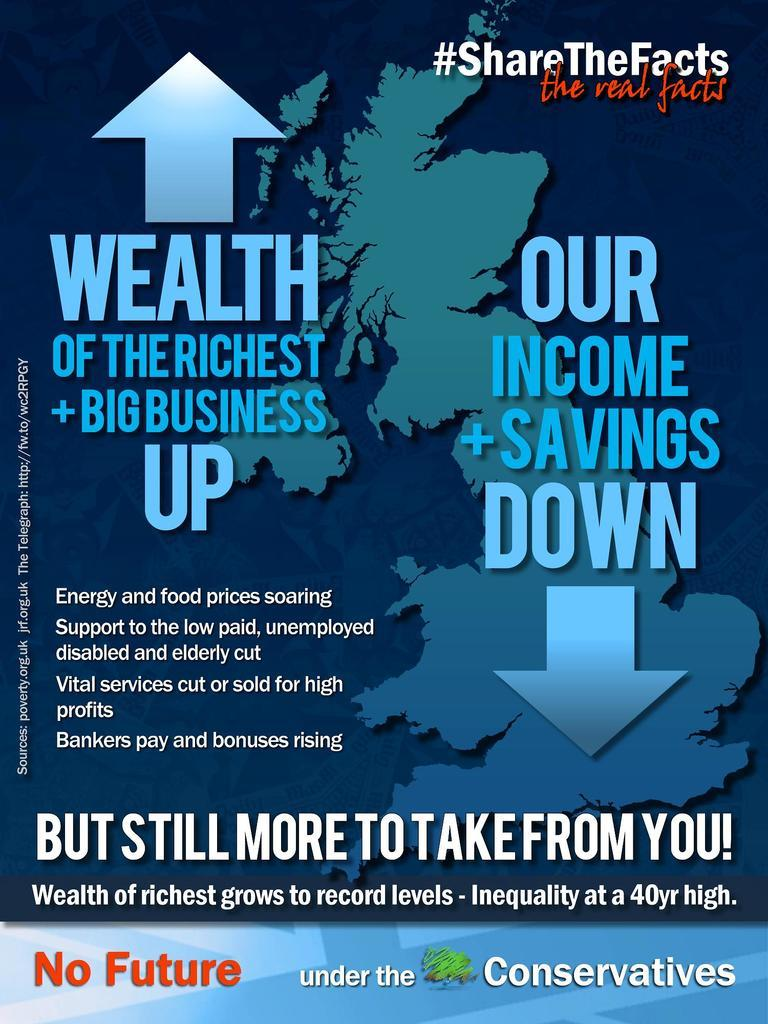<image>
Summarize the visual content of the image. An ad for no future under the conservatives. 